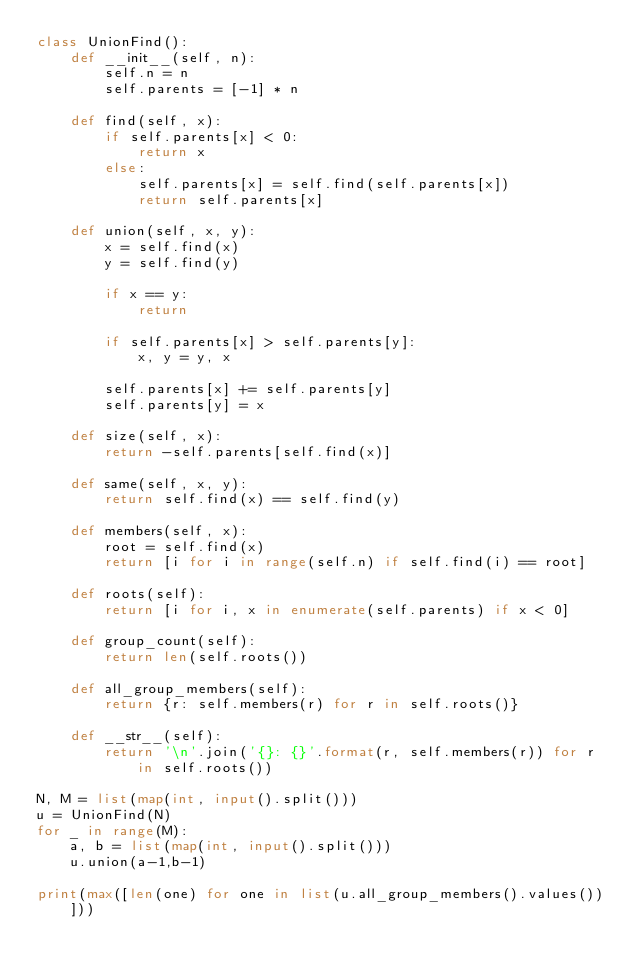Convert code to text. <code><loc_0><loc_0><loc_500><loc_500><_Python_>class UnionFind():
    def __init__(self, n):
        self.n = n
        self.parents = [-1] * n

    def find(self, x):
        if self.parents[x] < 0:
            return x
        else:
            self.parents[x] = self.find(self.parents[x])
            return self.parents[x]

    def union(self, x, y):
        x = self.find(x)
        y = self.find(y)

        if x == y:
            return

        if self.parents[x] > self.parents[y]:
            x, y = y, x

        self.parents[x] += self.parents[y]
        self.parents[y] = x

    def size(self, x):
        return -self.parents[self.find(x)]

    def same(self, x, y):
        return self.find(x) == self.find(y)

    def members(self, x):
        root = self.find(x)
        return [i for i in range(self.n) if self.find(i) == root]

    def roots(self):
        return [i for i, x in enumerate(self.parents) if x < 0]

    def group_count(self):
        return len(self.roots())

    def all_group_members(self):
        return {r: self.members(r) for r in self.roots()}

    def __str__(self):
        return '\n'.join('{}: {}'.format(r, self.members(r)) for r in self.roots())

N, M = list(map(int, input().split()))
u = UnionFind(N)
for _ in range(M):
    a, b = list(map(int, input().split()))
    u.union(a-1,b-1)

print(max([len(one) for one in list(u.all_group_members().values())]))


</code> 